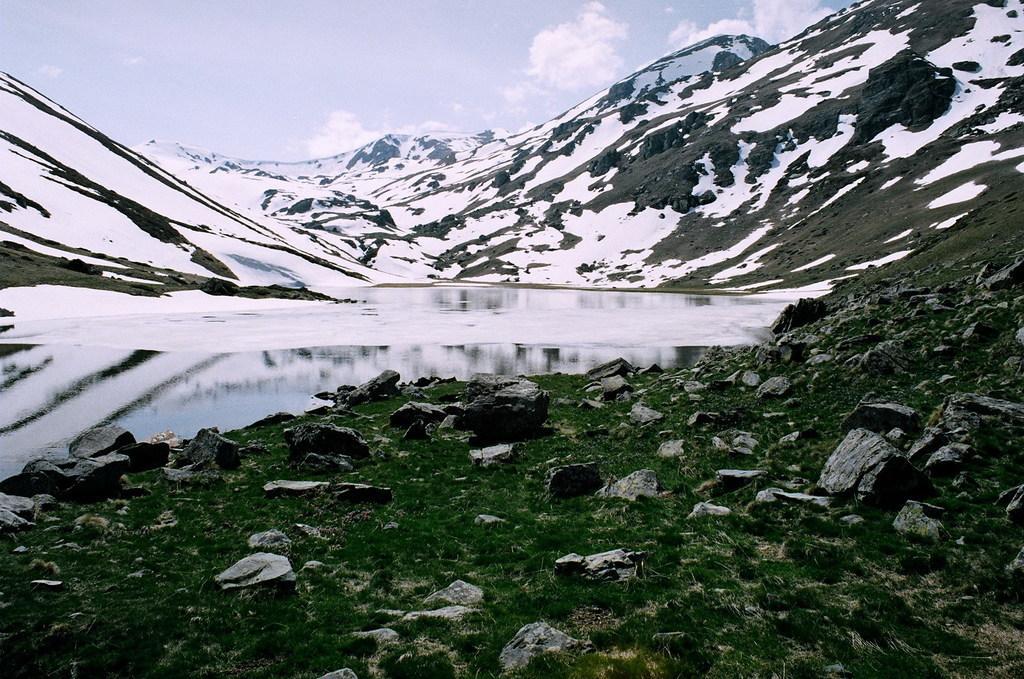How would you summarize this image in a sentence or two? This image is taken outdoors. At the top of the image there is a sky with clouds. At the bottom of the image there is a ground with grass and a few rocks on it. In the middle of the image there are a few hills covered with snow and there is a pond with water. 